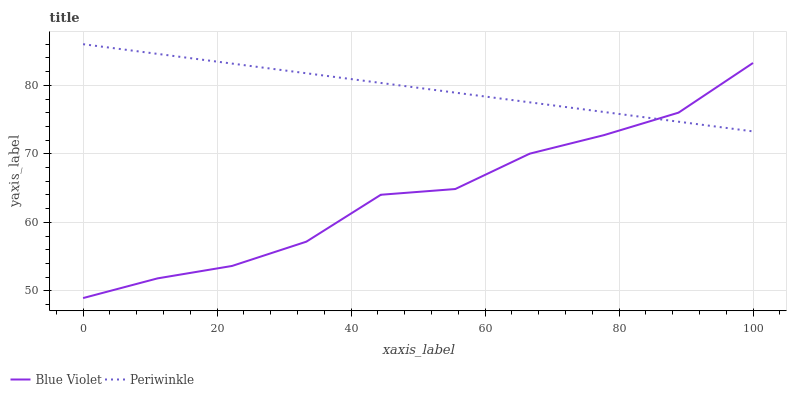Does Blue Violet have the minimum area under the curve?
Answer yes or no. Yes. Does Periwinkle have the maximum area under the curve?
Answer yes or no. Yes. Does Blue Violet have the maximum area under the curve?
Answer yes or no. No. Is Periwinkle the smoothest?
Answer yes or no. Yes. Is Blue Violet the roughest?
Answer yes or no. Yes. Is Blue Violet the smoothest?
Answer yes or no. No. Does Blue Violet have the lowest value?
Answer yes or no. Yes. Does Periwinkle have the highest value?
Answer yes or no. Yes. Does Blue Violet have the highest value?
Answer yes or no. No. Does Blue Violet intersect Periwinkle?
Answer yes or no. Yes. Is Blue Violet less than Periwinkle?
Answer yes or no. No. Is Blue Violet greater than Periwinkle?
Answer yes or no. No. 